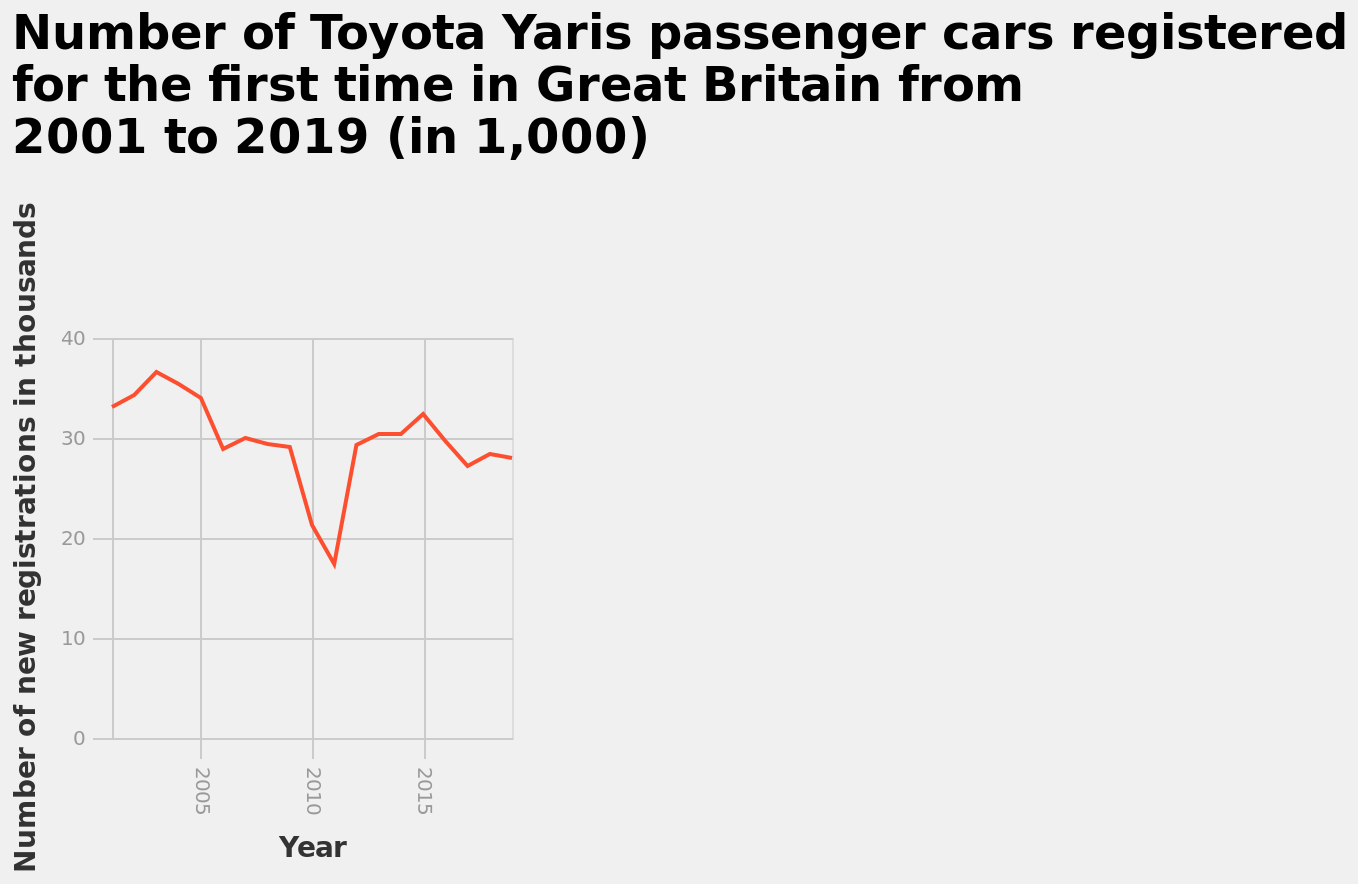<image>
please summary the statistics and relations of the chart This line graph shows that in 2001 the registration increased from 34000 to about 37000 in 2003. However in 2011 it decreased to below 20000 and then starting to increase in 2015 peaking over 31000. When did the dip in sales occur? The dip in sales occurred around 2010. 